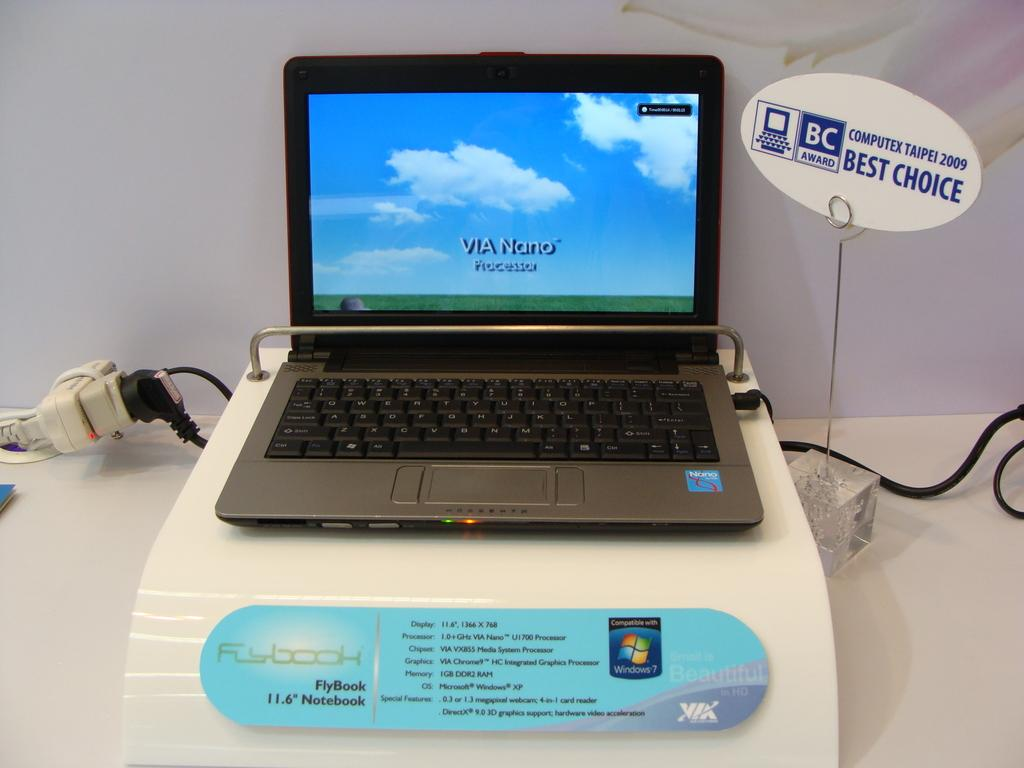<image>
Write a terse but informative summary of the picture. a computer that has the words Via Nano on it 